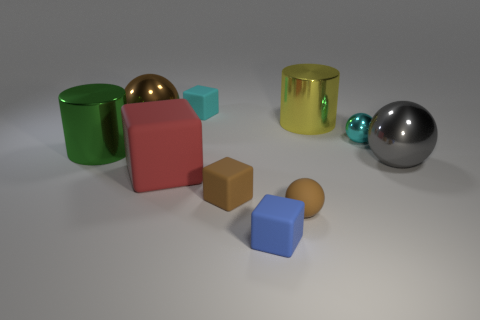What material is the other object that is the same shape as the large green shiny thing?
Your response must be concise. Metal. The large sphere that is left of the cyan sphere is what color?
Make the answer very short. Brown. What number of cylinders are either red matte things or tiny blue rubber objects?
Your answer should be compact. 0. How big is the green cylinder left of the matte object behind the yellow shiny cylinder?
Ensure brevity in your answer.  Large. There is a large rubber block; is its color the same as the shiny ball that is on the left side of the tiny shiny ball?
Your answer should be very brief. No. How many tiny rubber blocks are on the left side of the large gray metal object?
Provide a succinct answer. 3. Are there fewer small cyan balls than brown balls?
Offer a very short reply. Yes. There is a object that is on the left side of the small cyan rubber block and to the right of the big brown metallic ball; what size is it?
Offer a terse response. Large. There is a large cylinder that is on the left side of the yellow cylinder; is it the same color as the big matte object?
Your response must be concise. No. Are there fewer large metallic cylinders on the left side of the small blue matte block than yellow metal cylinders?
Offer a terse response. No. 